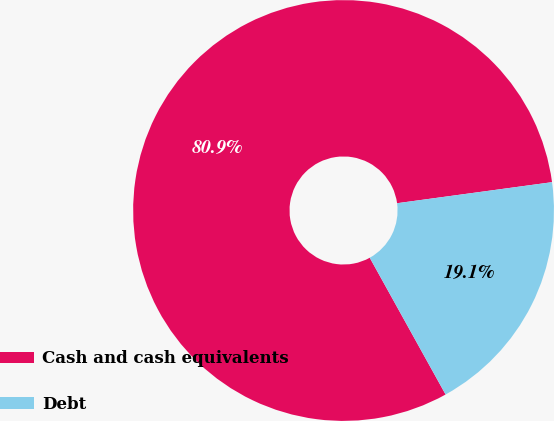Convert chart to OTSL. <chart><loc_0><loc_0><loc_500><loc_500><pie_chart><fcel>Cash and cash equivalents<fcel>Debt<nl><fcel>80.91%<fcel>19.09%<nl></chart> 